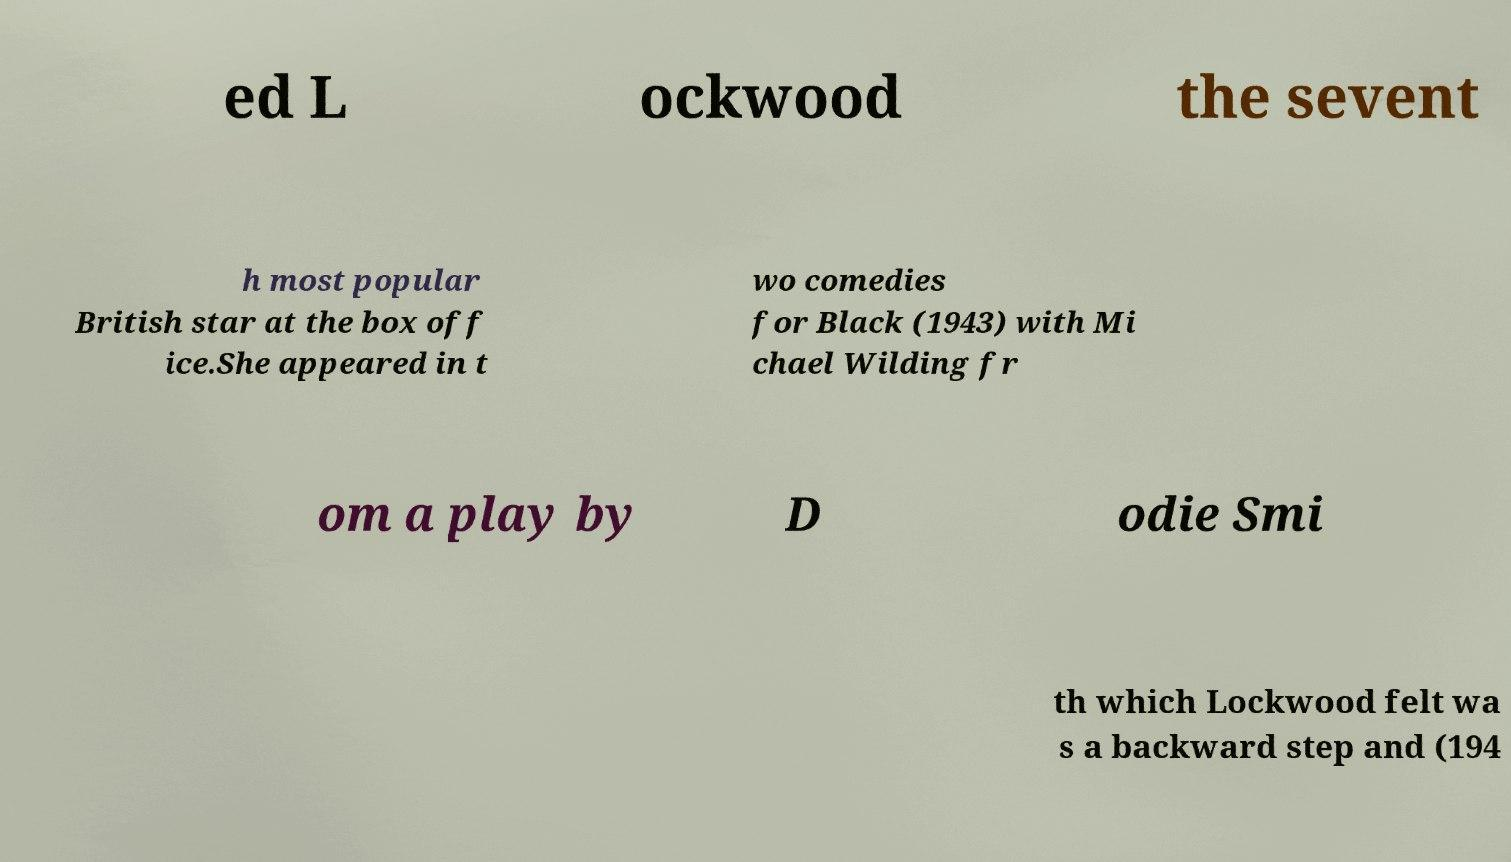Please read and relay the text visible in this image. What does it say? ed L ockwood the sevent h most popular British star at the box off ice.She appeared in t wo comedies for Black (1943) with Mi chael Wilding fr om a play by D odie Smi th which Lockwood felt wa s a backward step and (194 